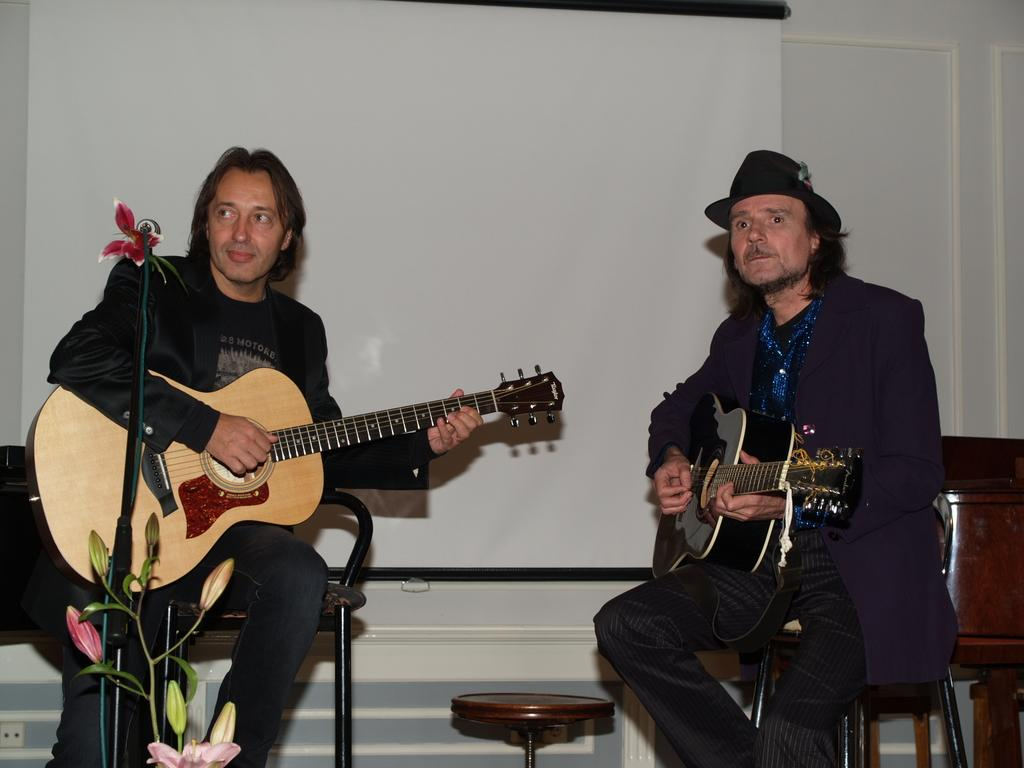How many people are in the image? There are two persons in the image. What are the persons doing in the image? The persons are sitting on chairs and playing guitar. Can you describe the color scheme of the image? There is a white color present in the image. What type of story is being told by the persons in the image? There is no indication in the image that the persons are telling a story. Can you describe the balls that are being smashed in the image? There are no balls or smashing actions present in the image. 